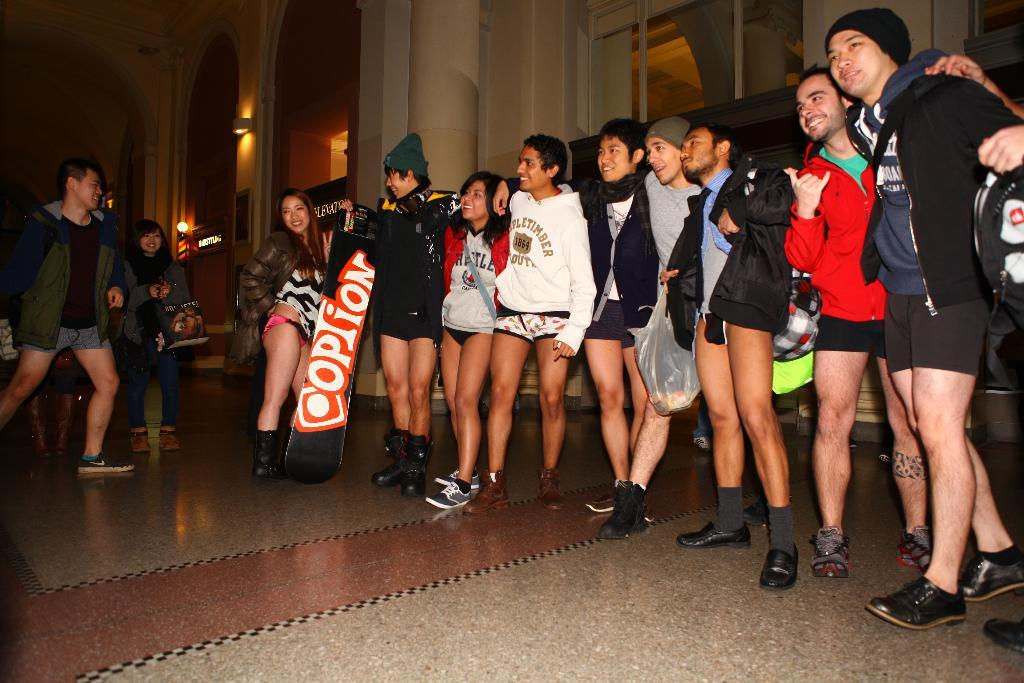<image>
Provide a brief description of the given image. A board that says option is help up by a man standing in a row. 